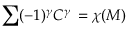<formula> <loc_0><loc_0><loc_500><loc_500>\sum ( - 1 ) ^ { \gamma } C ^ { \gamma } \, = \chi ( M )</formula> 